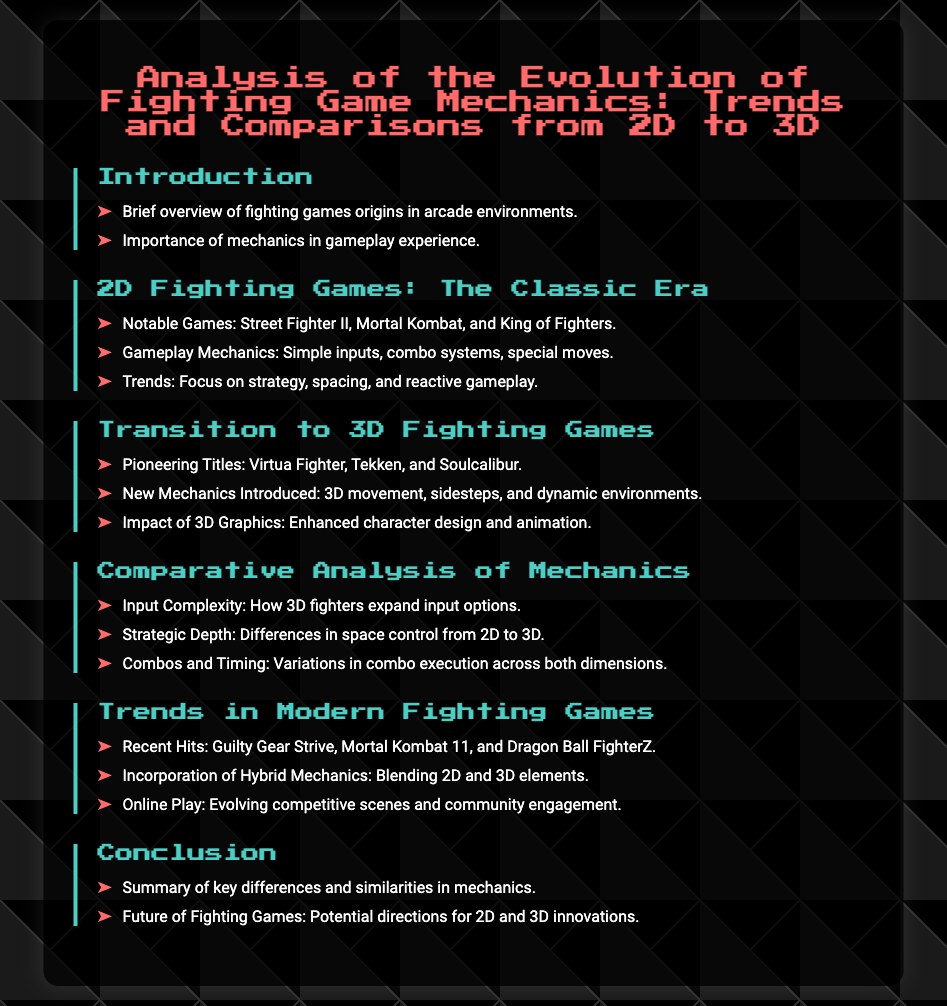What are the notable 2D fighting games mentioned? The document lists specific titles that represent significant contributions to 2D fighting games.
Answer: Street Fighter II, Mortal Kombat, King of Fighters What is a key feature introduced in 3D fighting games? The document highlights a distinct improvement that changed gameplay mechanics in 3D fighting games compared to 2D.
Answer: 3D movement Which game from the modern era is mentioned? The document cites recent popular titles to exemplify current trends in fighting games.
Answer: Guilty Gear Strive What key element of 2D gameplay is emphasized? The document describes how 2D games focus on a particular aspect of gameplay, contributing to competitive strategies.
Answer: Strategy What type of mechanics are blended in modern fighting games? The document discusses the evolution of mechanics in contemporary games by combining elements from different dimensions.
Answer: Hybrid Mechanics How do 3D fighting games enhance character design? The document notes a specific advancement in graphics that benefits the visual representation of characters.
Answer: Enhanced character design What is one of the pioneering titles in 3D fighting games? The document references significant early 3D titles that shaped the genre.
Answer: Virtua Fighter What is the importance of mechanics in fighting games? The document addresses the role mechanics play in creating an engaging gameplay experience.
Answer: Important 